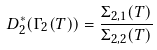<formula> <loc_0><loc_0><loc_500><loc_500>\ D _ { 2 } ^ { \ast } ( \Gamma _ { 2 } ( T ) ) = \frac { \Sigma _ { 2 , 1 } ( T ) } { \Sigma _ { 2 , 2 } ( T ) }</formula> 